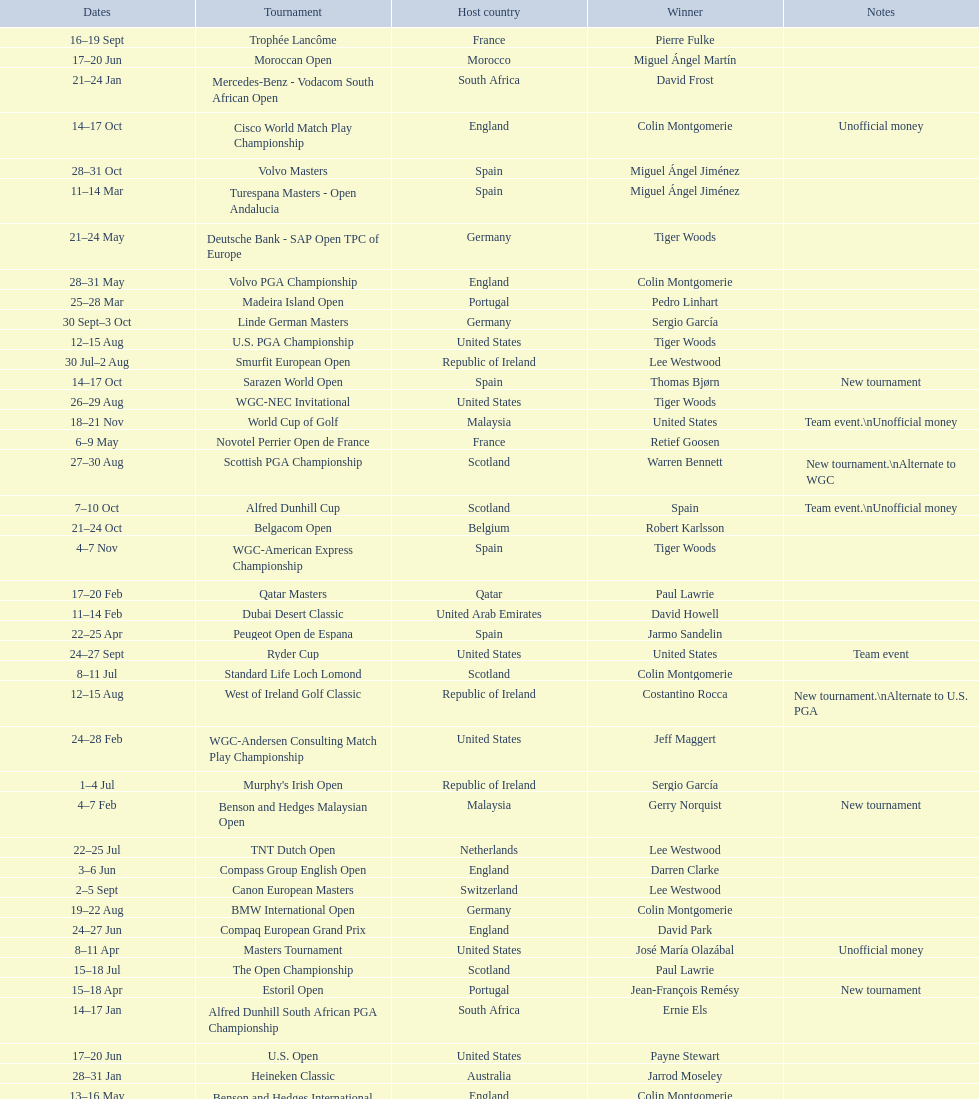Does any country have more than 5 winners? Yes. 